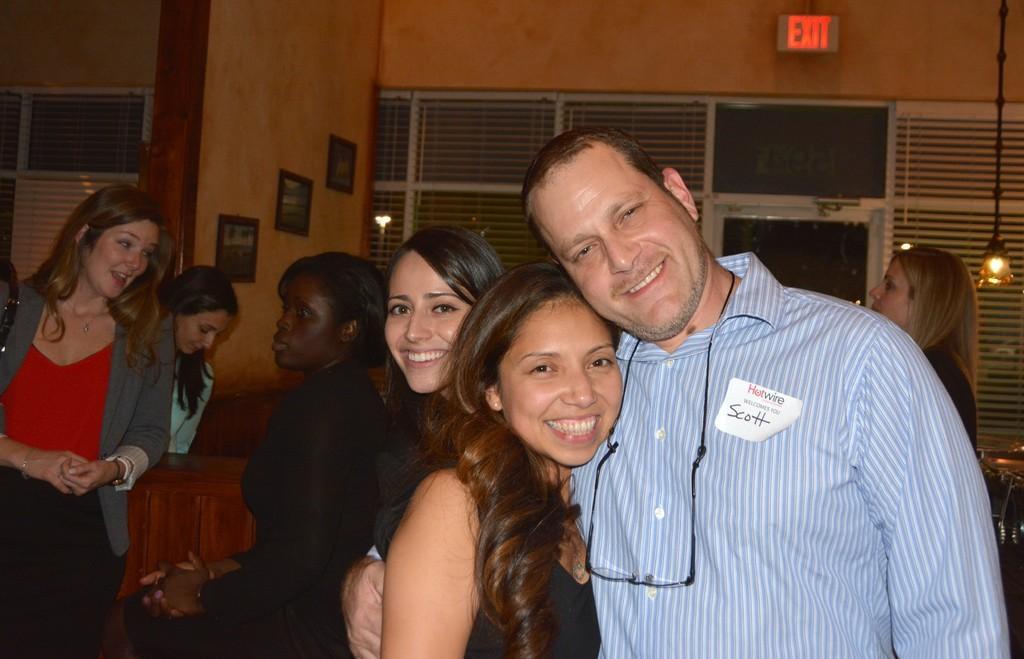Please provide a concise description of this image. Here we can see a group of people standing and mostly all of them all laughing and at the top right there is a symbol of exit and on the wall there are some portraits 